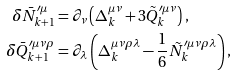Convert formula to latex. <formula><loc_0><loc_0><loc_500><loc_500>\delta \bar { N } _ { k + 1 } ^ { \prime \mu } & = \partial _ { \nu } \left ( \Delta _ { k } ^ { \mu \nu } + 3 \tilde { Q } _ { k } ^ { \prime \mu \nu } \right ) , \\ \delta \bar { Q } _ { k + 1 } ^ { \prime \mu \nu \rho } & = \partial _ { \lambda } \left ( \Delta _ { k } ^ { \mu \nu \rho \lambda } - \frac { 1 } { 6 } \tilde { N } _ { k } ^ { \prime \mu \nu \rho \lambda } \right ) ,</formula> 